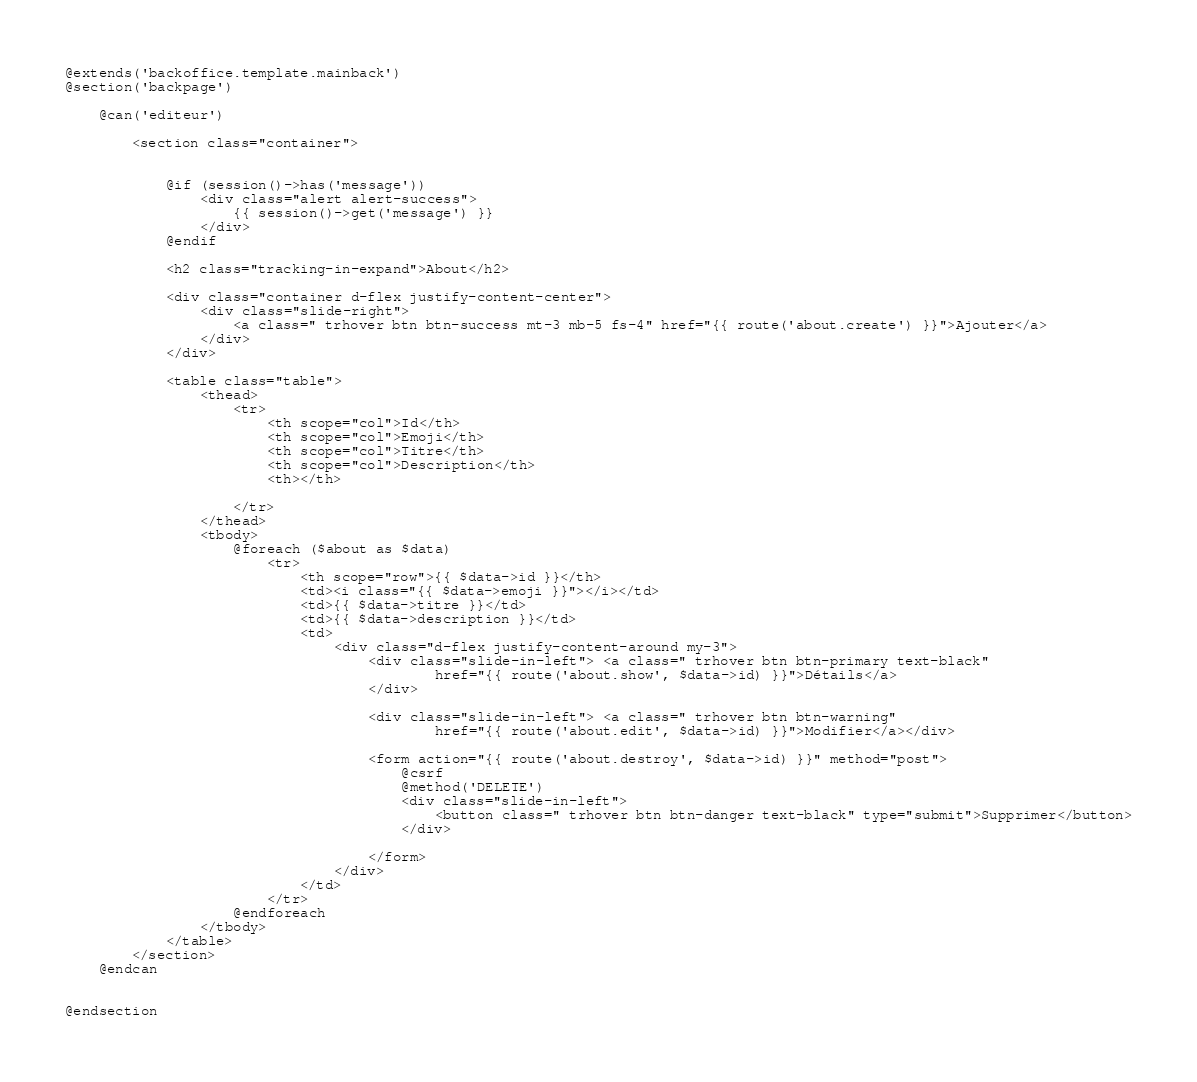<code> <loc_0><loc_0><loc_500><loc_500><_PHP_>@extends('backoffice.template.mainback')
@section('backpage')

    @can('editeur')

        <section class="container">


            @if (session()->has('message'))
                <div class="alert alert-success">
                    {{ session()->get('message') }}
                </div>
            @endif

            <h2 class="tracking-in-expand">About</h2>

            <div class="container d-flex justify-content-center">
                <div class="slide-right">
                    <a class=" trhover btn btn-success mt-3 mb-5 fs-4" href="{{ route('about.create') }}">Ajouter</a>
                </div>
            </div>

            <table class="table">
                <thead>
                    <tr>
                        <th scope="col">Id</th>
                        <th scope="col">Emoji</th>
                        <th scope="col">Titre</th>
                        <th scope="col">Description</th>
                        <th></th>

                    </tr>
                </thead>
                <tbody>
                    @foreach ($about as $data)
                        <tr>
                            <th scope="row">{{ $data->id }}</th>
                            <td><i class="{{ $data->emoji }}"></i></td>
                            <td>{{ $data->titre }}</td>
                            <td>{{ $data->description }}</td>
                            <td>
                                <div class="d-flex justify-content-around my-3">
                                    <div class="slide-in-left"> <a class=" trhover btn btn-primary text-black"
                                            href="{{ route('about.show', $data->id) }}">Détails</a>
                                    </div>

                                    <div class="slide-in-left"> <a class=" trhover btn btn-warning"
                                            href="{{ route('about.edit', $data->id) }}">Modifier</a></div>

                                    <form action="{{ route('about.destroy', $data->id) }}" method="post">
                                        @csrf
                                        @method('DELETE')
                                        <div class="slide-in-left">
                                            <button class=" trhover btn btn-danger text-black" type="submit">Supprimer</button>
                                        </div>

                                    </form>
                                </div>
                            </td>
                        </tr>
                    @endforeach
                </tbody>
            </table>
        </section>
    @endcan


@endsection
</code> 